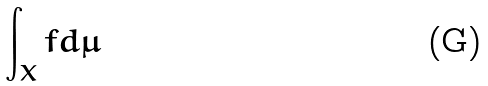Convert formula to latex. <formula><loc_0><loc_0><loc_500><loc_500>\int _ { X } f d \mu</formula> 